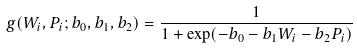Convert formula to latex. <formula><loc_0><loc_0><loc_500><loc_500>g ( W _ { i } , P _ { i } ; b _ { 0 } , b _ { 1 } , b _ { 2 } ) = \frac { 1 } { 1 + \exp ( - b _ { 0 } - b _ { 1 } W _ { i } - b _ { 2 } P _ { i } ) }</formula> 